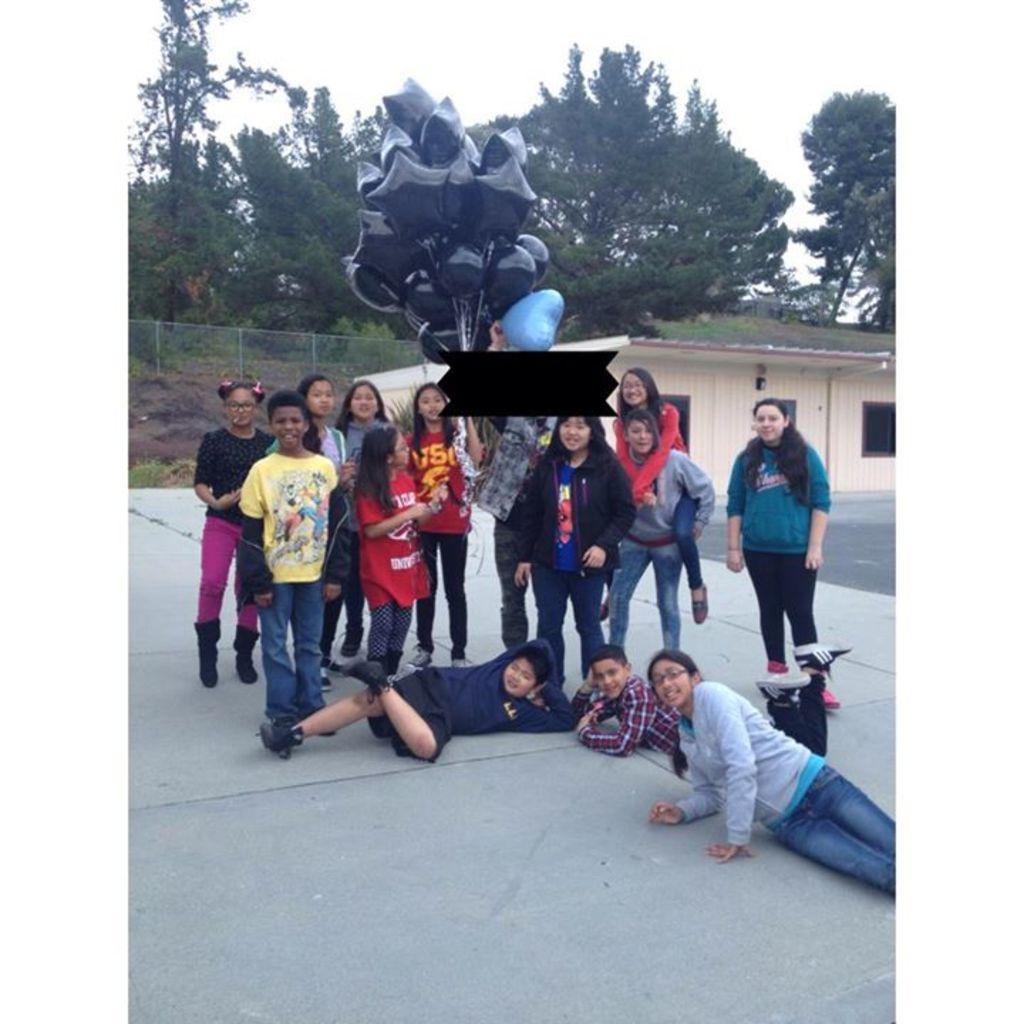Could you give a brief overview of what you see in this image? In the image there are a group of people posing for the photo and one among them is holding a lot of balloons, behind them there are many trees. 